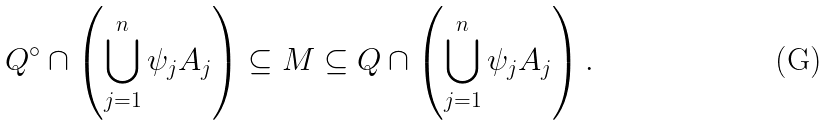<formula> <loc_0><loc_0><loc_500><loc_500>Q ^ { \circ } \cap \left ( \bigcup _ { j = 1 } ^ { n } \psi _ { j } A _ { j } \right ) \subseteq M \subseteq Q \cap \left ( \bigcup _ { j = 1 } ^ { n } \psi _ { j } A _ { j } \right ) .</formula> 